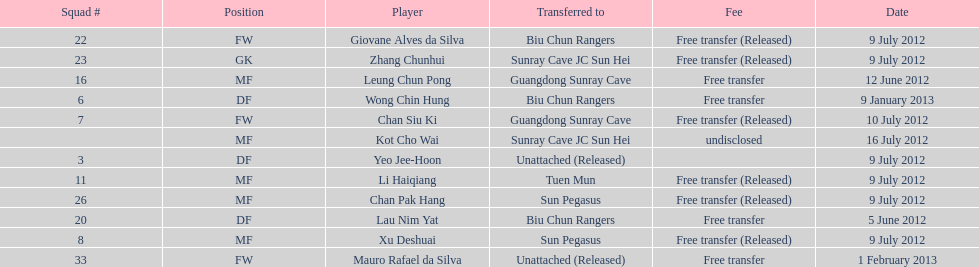Which team did lau nim yat play for after he was transferred? Biu Chun Rangers. 